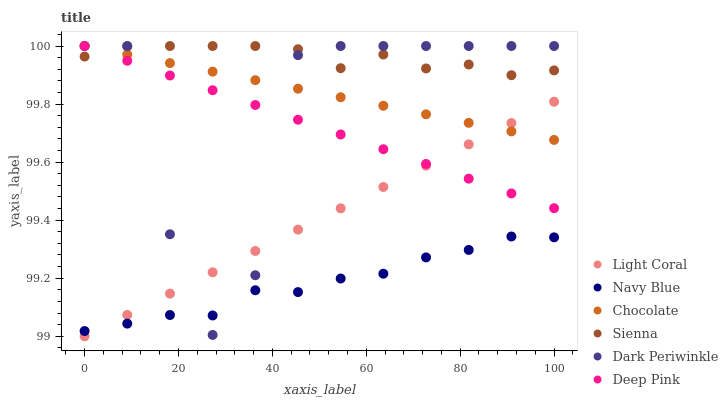Does Navy Blue have the minimum area under the curve?
Answer yes or no. Yes. Does Sienna have the maximum area under the curve?
Answer yes or no. Yes. Does Deep Pink have the minimum area under the curve?
Answer yes or no. No. Does Deep Pink have the maximum area under the curve?
Answer yes or no. No. Is Chocolate the smoothest?
Answer yes or no. Yes. Is Dark Periwinkle the roughest?
Answer yes or no. Yes. Is Deep Pink the smoothest?
Answer yes or no. No. Is Deep Pink the roughest?
Answer yes or no. No. Does Light Coral have the lowest value?
Answer yes or no. Yes. Does Deep Pink have the lowest value?
Answer yes or no. No. Does Dark Periwinkle have the highest value?
Answer yes or no. Yes. Does Navy Blue have the highest value?
Answer yes or no. No. Is Navy Blue less than Deep Pink?
Answer yes or no. Yes. Is Sienna greater than Light Coral?
Answer yes or no. Yes. Does Navy Blue intersect Dark Periwinkle?
Answer yes or no. Yes. Is Navy Blue less than Dark Periwinkle?
Answer yes or no. No. Is Navy Blue greater than Dark Periwinkle?
Answer yes or no. No. Does Navy Blue intersect Deep Pink?
Answer yes or no. No. 